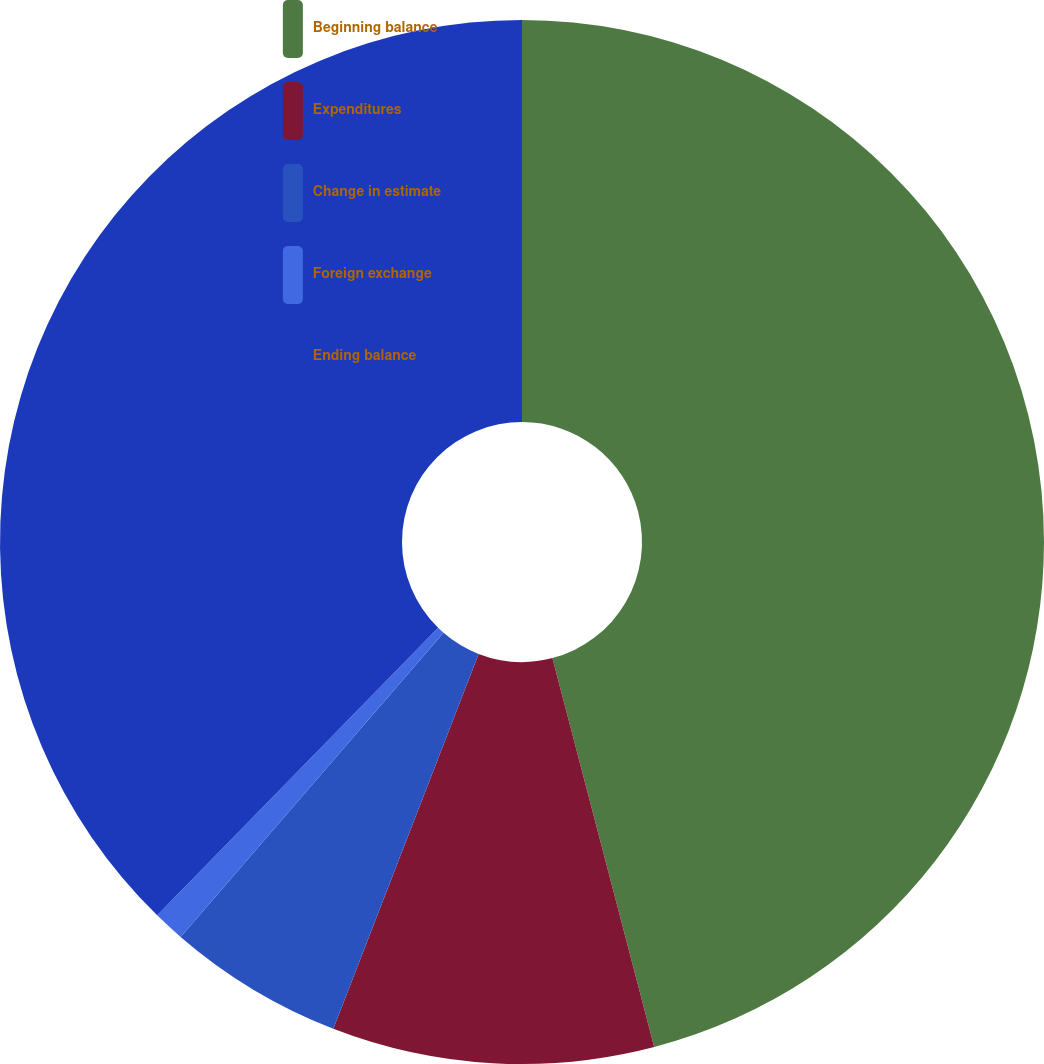Convert chart to OTSL. <chart><loc_0><loc_0><loc_500><loc_500><pie_chart><fcel>Beginning balance<fcel>Expenditures<fcel>Change in estimate<fcel>Foreign exchange<fcel>Ending balance<nl><fcel>45.92%<fcel>9.96%<fcel>5.46%<fcel>0.97%<fcel>37.68%<nl></chart> 